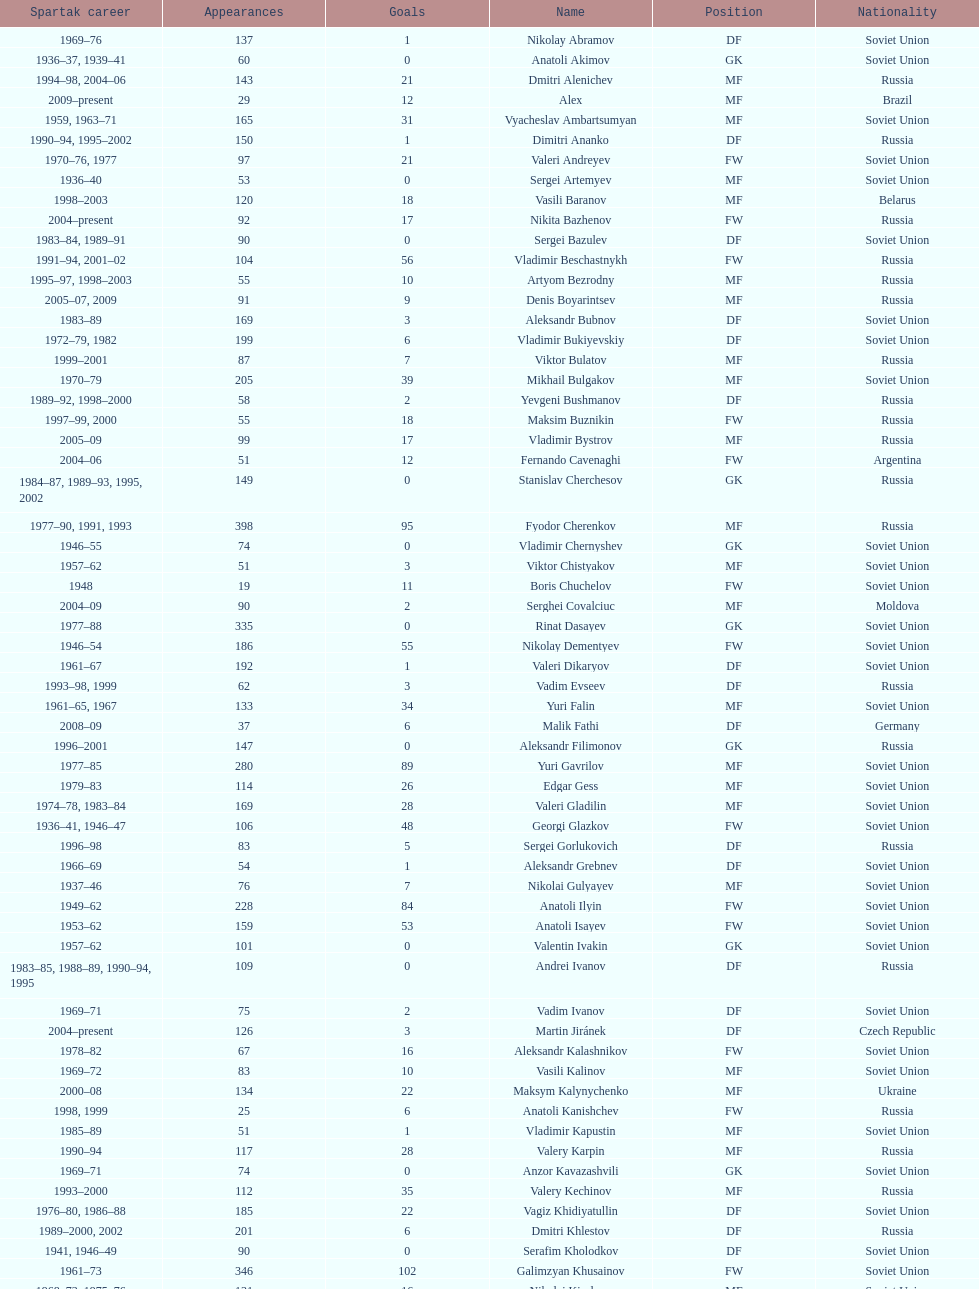Which player has the highest number of goals? Nikita Simonyan. 